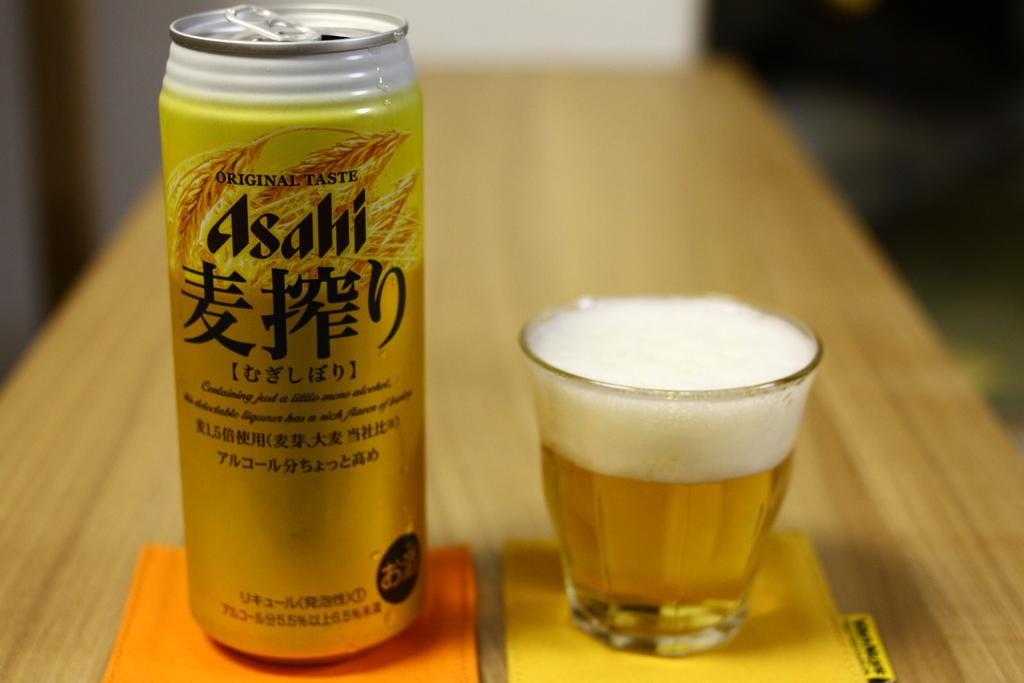<image>
Describe the image concisely. An original taste Asahi beer can sitting next to a glass filled with the beer. 